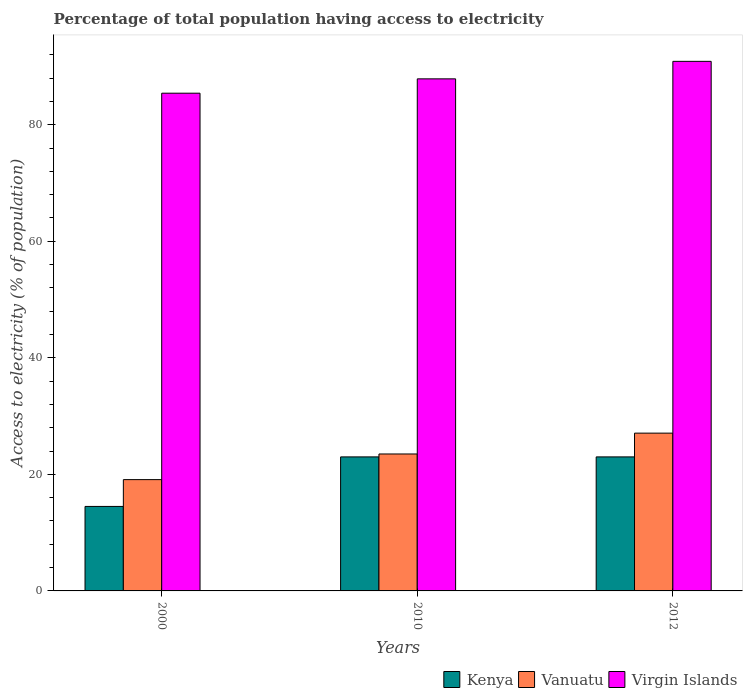How many different coloured bars are there?
Provide a succinct answer. 3. How many groups of bars are there?
Give a very brief answer. 3. Are the number of bars per tick equal to the number of legend labels?
Make the answer very short. Yes. In how many cases, is the number of bars for a given year not equal to the number of legend labels?
Ensure brevity in your answer.  0. Across all years, what is the maximum percentage of population that have access to electricity in Vanuatu?
Provide a short and direct response. 27.08. Across all years, what is the minimum percentage of population that have access to electricity in Virgin Islands?
Offer a terse response. 85.41. What is the total percentage of population that have access to electricity in Kenya in the graph?
Provide a succinct answer. 60.5. What is the difference between the percentage of population that have access to electricity in Virgin Islands in 2000 and that in 2012?
Provide a short and direct response. -5.46. What is the difference between the percentage of population that have access to electricity in Kenya in 2000 and the percentage of population that have access to electricity in Vanuatu in 2010?
Your answer should be compact. -9. What is the average percentage of population that have access to electricity in Vanuatu per year?
Your response must be concise. 23.23. In the year 2012, what is the difference between the percentage of population that have access to electricity in Virgin Islands and percentage of population that have access to electricity in Kenya?
Offer a very short reply. 67.88. What is the ratio of the percentage of population that have access to electricity in Virgin Islands in 2000 to that in 2012?
Your answer should be compact. 0.94. Is the percentage of population that have access to electricity in Virgin Islands in 2000 less than that in 2012?
Make the answer very short. Yes. What is the difference between the highest and the second highest percentage of population that have access to electricity in Vanuatu?
Provide a short and direct response. 3.58. What is the difference between the highest and the lowest percentage of population that have access to electricity in Virgin Islands?
Your answer should be compact. 5.46. In how many years, is the percentage of population that have access to electricity in Virgin Islands greater than the average percentage of population that have access to electricity in Virgin Islands taken over all years?
Your answer should be compact. 1. What does the 1st bar from the left in 2010 represents?
Keep it short and to the point. Kenya. What does the 2nd bar from the right in 2012 represents?
Provide a short and direct response. Vanuatu. Are all the bars in the graph horizontal?
Offer a terse response. No. How many years are there in the graph?
Your answer should be very brief. 3. Are the values on the major ticks of Y-axis written in scientific E-notation?
Make the answer very short. No. Does the graph contain any zero values?
Offer a terse response. No. How many legend labels are there?
Your answer should be compact. 3. What is the title of the graph?
Offer a terse response. Percentage of total population having access to electricity. What is the label or title of the X-axis?
Your answer should be very brief. Years. What is the label or title of the Y-axis?
Your response must be concise. Access to electricity (% of population). What is the Access to electricity (% of population) in Kenya in 2000?
Your answer should be very brief. 14.5. What is the Access to electricity (% of population) of Virgin Islands in 2000?
Give a very brief answer. 85.41. What is the Access to electricity (% of population) of Kenya in 2010?
Give a very brief answer. 23. What is the Access to electricity (% of population) of Vanuatu in 2010?
Your answer should be compact. 23.5. What is the Access to electricity (% of population) in Virgin Islands in 2010?
Give a very brief answer. 87.87. What is the Access to electricity (% of population) of Vanuatu in 2012?
Ensure brevity in your answer.  27.08. What is the Access to electricity (% of population) of Virgin Islands in 2012?
Offer a very short reply. 90.88. Across all years, what is the maximum Access to electricity (% of population) of Vanuatu?
Offer a very short reply. 27.08. Across all years, what is the maximum Access to electricity (% of population) in Virgin Islands?
Provide a succinct answer. 90.88. Across all years, what is the minimum Access to electricity (% of population) of Kenya?
Offer a very short reply. 14.5. Across all years, what is the minimum Access to electricity (% of population) of Vanuatu?
Your answer should be very brief. 19.1. Across all years, what is the minimum Access to electricity (% of population) in Virgin Islands?
Ensure brevity in your answer.  85.41. What is the total Access to electricity (% of population) of Kenya in the graph?
Provide a succinct answer. 60.5. What is the total Access to electricity (% of population) of Vanuatu in the graph?
Give a very brief answer. 69.68. What is the total Access to electricity (% of population) of Virgin Islands in the graph?
Your answer should be compact. 264.16. What is the difference between the Access to electricity (% of population) of Vanuatu in 2000 and that in 2010?
Provide a succinct answer. -4.4. What is the difference between the Access to electricity (% of population) of Virgin Islands in 2000 and that in 2010?
Your answer should be very brief. -2.46. What is the difference between the Access to electricity (% of population) in Kenya in 2000 and that in 2012?
Make the answer very short. -8.5. What is the difference between the Access to electricity (% of population) in Vanuatu in 2000 and that in 2012?
Offer a very short reply. -7.98. What is the difference between the Access to electricity (% of population) of Virgin Islands in 2000 and that in 2012?
Offer a very short reply. -5.46. What is the difference between the Access to electricity (% of population) in Kenya in 2010 and that in 2012?
Your response must be concise. 0. What is the difference between the Access to electricity (% of population) in Vanuatu in 2010 and that in 2012?
Provide a short and direct response. -3.58. What is the difference between the Access to electricity (% of population) of Virgin Islands in 2010 and that in 2012?
Offer a very short reply. -3. What is the difference between the Access to electricity (% of population) of Kenya in 2000 and the Access to electricity (% of population) of Virgin Islands in 2010?
Provide a short and direct response. -73.37. What is the difference between the Access to electricity (% of population) in Vanuatu in 2000 and the Access to electricity (% of population) in Virgin Islands in 2010?
Give a very brief answer. -68.77. What is the difference between the Access to electricity (% of population) in Kenya in 2000 and the Access to electricity (% of population) in Vanuatu in 2012?
Provide a succinct answer. -12.58. What is the difference between the Access to electricity (% of population) of Kenya in 2000 and the Access to electricity (% of population) of Virgin Islands in 2012?
Offer a very short reply. -76.38. What is the difference between the Access to electricity (% of population) of Vanuatu in 2000 and the Access to electricity (% of population) of Virgin Islands in 2012?
Your answer should be compact. -71.78. What is the difference between the Access to electricity (% of population) of Kenya in 2010 and the Access to electricity (% of population) of Vanuatu in 2012?
Offer a terse response. -4.08. What is the difference between the Access to electricity (% of population) in Kenya in 2010 and the Access to electricity (% of population) in Virgin Islands in 2012?
Your answer should be compact. -67.88. What is the difference between the Access to electricity (% of population) in Vanuatu in 2010 and the Access to electricity (% of population) in Virgin Islands in 2012?
Provide a succinct answer. -67.38. What is the average Access to electricity (% of population) of Kenya per year?
Make the answer very short. 20.17. What is the average Access to electricity (% of population) of Vanuatu per year?
Provide a short and direct response. 23.23. What is the average Access to electricity (% of population) in Virgin Islands per year?
Make the answer very short. 88.05. In the year 2000, what is the difference between the Access to electricity (% of population) in Kenya and Access to electricity (% of population) in Virgin Islands?
Provide a short and direct response. -70.91. In the year 2000, what is the difference between the Access to electricity (% of population) of Vanuatu and Access to electricity (% of population) of Virgin Islands?
Offer a very short reply. -66.31. In the year 2010, what is the difference between the Access to electricity (% of population) of Kenya and Access to electricity (% of population) of Vanuatu?
Offer a terse response. -0.5. In the year 2010, what is the difference between the Access to electricity (% of population) of Kenya and Access to electricity (% of population) of Virgin Islands?
Your answer should be very brief. -64.87. In the year 2010, what is the difference between the Access to electricity (% of population) in Vanuatu and Access to electricity (% of population) in Virgin Islands?
Make the answer very short. -64.37. In the year 2012, what is the difference between the Access to electricity (% of population) in Kenya and Access to electricity (% of population) in Vanuatu?
Make the answer very short. -4.08. In the year 2012, what is the difference between the Access to electricity (% of population) in Kenya and Access to electricity (% of population) in Virgin Islands?
Make the answer very short. -67.88. In the year 2012, what is the difference between the Access to electricity (% of population) of Vanuatu and Access to electricity (% of population) of Virgin Islands?
Provide a succinct answer. -63.8. What is the ratio of the Access to electricity (% of population) of Kenya in 2000 to that in 2010?
Your response must be concise. 0.63. What is the ratio of the Access to electricity (% of population) in Vanuatu in 2000 to that in 2010?
Keep it short and to the point. 0.81. What is the ratio of the Access to electricity (% of population) in Kenya in 2000 to that in 2012?
Your response must be concise. 0.63. What is the ratio of the Access to electricity (% of population) in Vanuatu in 2000 to that in 2012?
Keep it short and to the point. 0.71. What is the ratio of the Access to electricity (% of population) in Virgin Islands in 2000 to that in 2012?
Your answer should be compact. 0.94. What is the ratio of the Access to electricity (% of population) of Vanuatu in 2010 to that in 2012?
Your answer should be very brief. 0.87. What is the difference between the highest and the second highest Access to electricity (% of population) of Vanuatu?
Your response must be concise. 3.58. What is the difference between the highest and the second highest Access to electricity (% of population) in Virgin Islands?
Provide a succinct answer. 3. What is the difference between the highest and the lowest Access to electricity (% of population) in Kenya?
Your answer should be very brief. 8.5. What is the difference between the highest and the lowest Access to electricity (% of population) of Vanuatu?
Keep it short and to the point. 7.98. What is the difference between the highest and the lowest Access to electricity (% of population) in Virgin Islands?
Your answer should be compact. 5.46. 